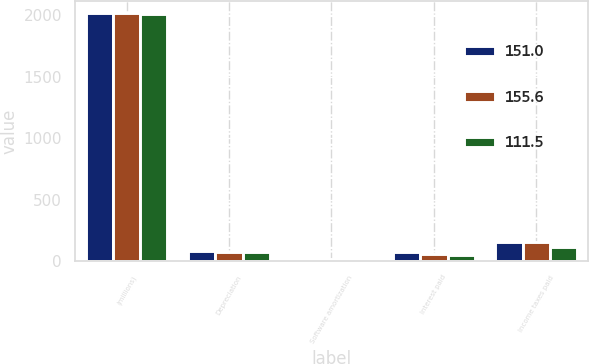<chart> <loc_0><loc_0><loc_500><loc_500><stacked_bar_chart><ecel><fcel>(millions)<fcel>Depreciation<fcel>Software amortization<fcel>Interest paid<fcel>Income taxes paid<nl><fcel>151<fcel>2017<fcel>85.2<fcel>14.5<fcel>72.1<fcel>155.6<nl><fcel>155.6<fcel>2016<fcel>71.2<fcel>17.1<fcel>57.5<fcel>151<nl><fcel>111.5<fcel>2015<fcel>71.5<fcel>18.1<fcel>52.2<fcel>111.5<nl></chart> 